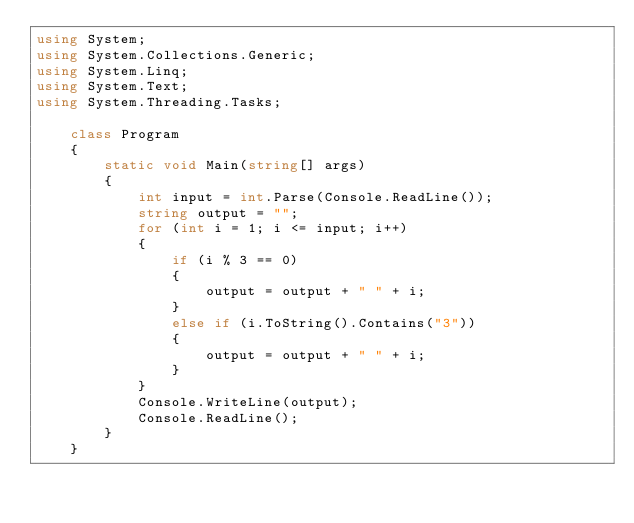<code> <loc_0><loc_0><loc_500><loc_500><_C#_>using System;
using System.Collections.Generic;
using System.Linq;
using System.Text;
using System.Threading.Tasks;

    class Program
    {
        static void Main(string[] args)
        {
            int input = int.Parse(Console.ReadLine());
            string output = "";
            for (int i = 1; i <= input; i++)
            {
                if (i % 3 == 0)
                {
                    output = output + " " + i;
                }
                else if (i.ToString().Contains("3"))
                {
                    output = output + " " + i;
                }
            }
            Console.WriteLine(output);
            Console.ReadLine();
        }
    }
</code> 